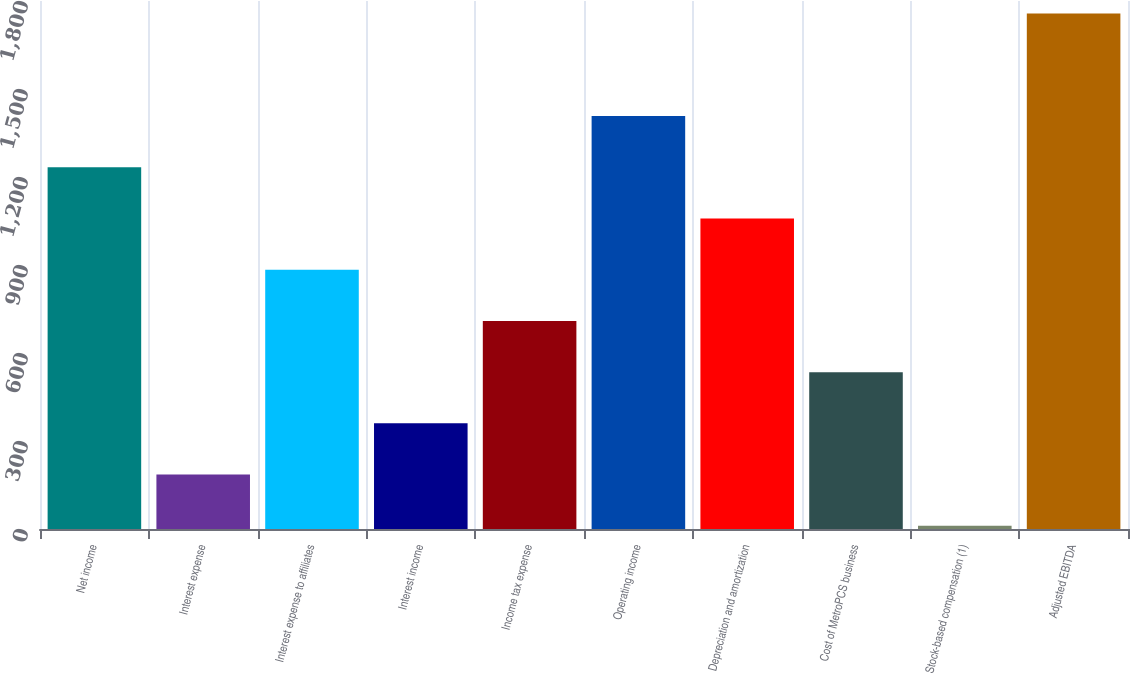Convert chart to OTSL. <chart><loc_0><loc_0><loc_500><loc_500><bar_chart><fcel>Net income<fcel>Interest expense<fcel>Interest expense to affiliates<fcel>Interest income<fcel>Income tax expense<fcel>Operating income<fcel>Depreciation and amortization<fcel>Cost of MetroPCS business<fcel>Stock-based compensation (1)<fcel>Adjusted EBITDA<nl><fcel>1233.2<fcel>185.6<fcel>884<fcel>360.2<fcel>709.4<fcel>1407.8<fcel>1058.6<fcel>534.8<fcel>11<fcel>1757<nl></chart> 